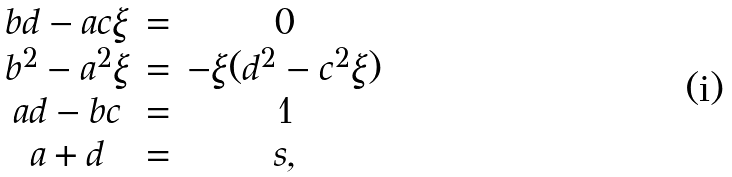<formula> <loc_0><loc_0><loc_500><loc_500>\begin{array} { c c c c c } b d - a c \xi & = & 0 \\ b ^ { 2 } - a ^ { 2 } \xi & = & - \xi ( d ^ { 2 } - c ^ { 2 } \xi ) \\ a d - b c & = & 1 \\ a + d & = & s , \end{array}</formula> 